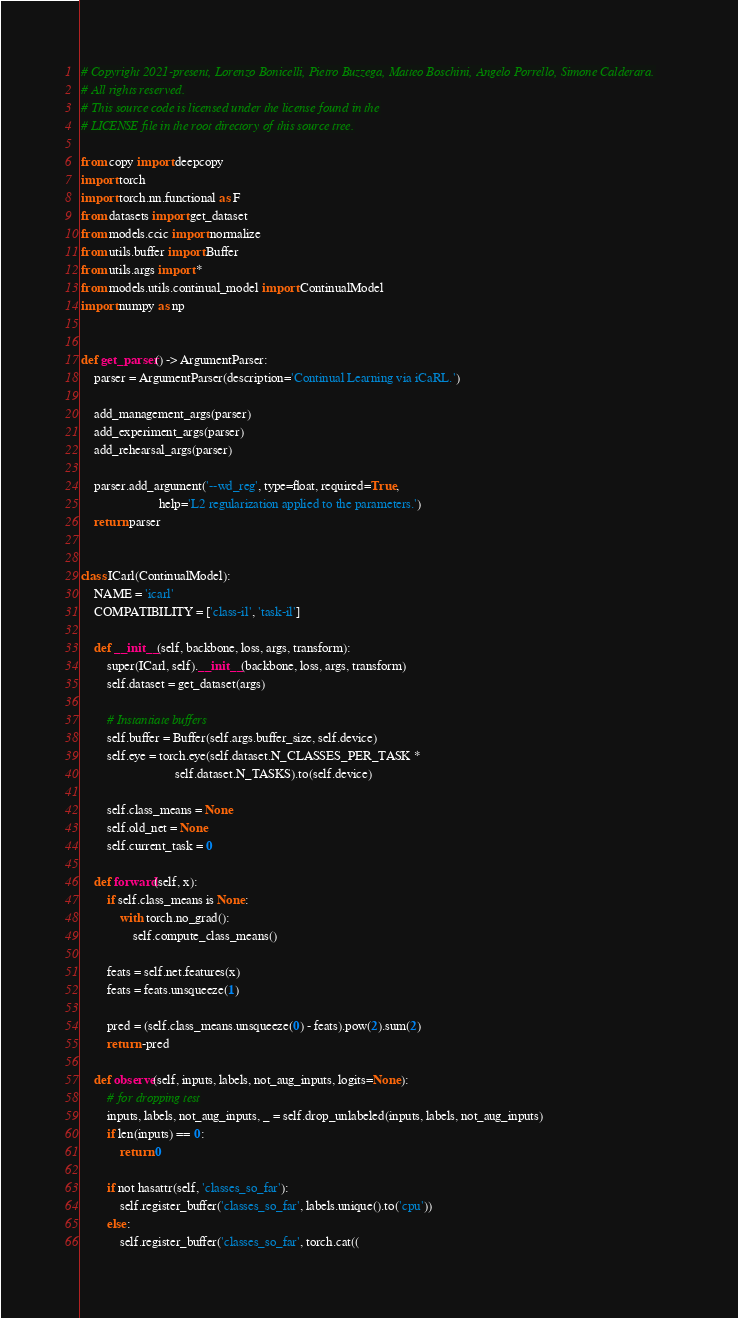Convert code to text. <code><loc_0><loc_0><loc_500><loc_500><_Python_># Copyright 2021-present, Lorenzo Bonicelli, Pietro Buzzega, Matteo Boschini, Angelo Porrello, Simone Calderara.
# All rights reserved.
# This source code is licensed under the license found in the
# LICENSE file in the root directory of this source tree.

from copy import deepcopy
import torch
import torch.nn.functional as F
from datasets import get_dataset
from models.ccic import normalize
from utils.buffer import Buffer
from utils.args import *
from models.utils.continual_model import ContinualModel
import numpy as np


def get_parser() -> ArgumentParser:
    parser = ArgumentParser(description='Continual Learning via iCaRL.')

    add_management_args(parser)
    add_experiment_args(parser)
    add_rehearsal_args(parser)

    parser.add_argument('--wd_reg', type=float, required=True,
                        help='L2 regularization applied to the parameters.')
    return parser


class ICarl(ContinualModel):
    NAME = 'icarl'
    COMPATIBILITY = ['class-il', 'task-il']

    def __init__(self, backbone, loss, args, transform):
        super(ICarl, self).__init__(backbone, loss, args, transform)
        self.dataset = get_dataset(args)

        # Instantiate buffers
        self.buffer = Buffer(self.args.buffer_size, self.device)
        self.eye = torch.eye(self.dataset.N_CLASSES_PER_TASK *
                             self.dataset.N_TASKS).to(self.device)

        self.class_means = None
        self.old_net = None
        self.current_task = 0

    def forward(self, x):
        if self.class_means is None:
            with torch.no_grad():
                self.compute_class_means()

        feats = self.net.features(x)
        feats = feats.unsqueeze(1)

        pred = (self.class_means.unsqueeze(0) - feats).pow(2).sum(2)
        return -pred

    def observe(self, inputs, labels, not_aug_inputs, logits=None):
        # for dropping test
        inputs, labels, not_aug_inputs, _ = self.drop_unlabeled(inputs, labels, not_aug_inputs)
        if len(inputs) == 0:
            return 0

        if not hasattr(self, 'classes_so_far'):
            self.register_buffer('classes_so_far', labels.unique().to('cpu'))
        else:
            self.register_buffer('classes_so_far', torch.cat((</code> 